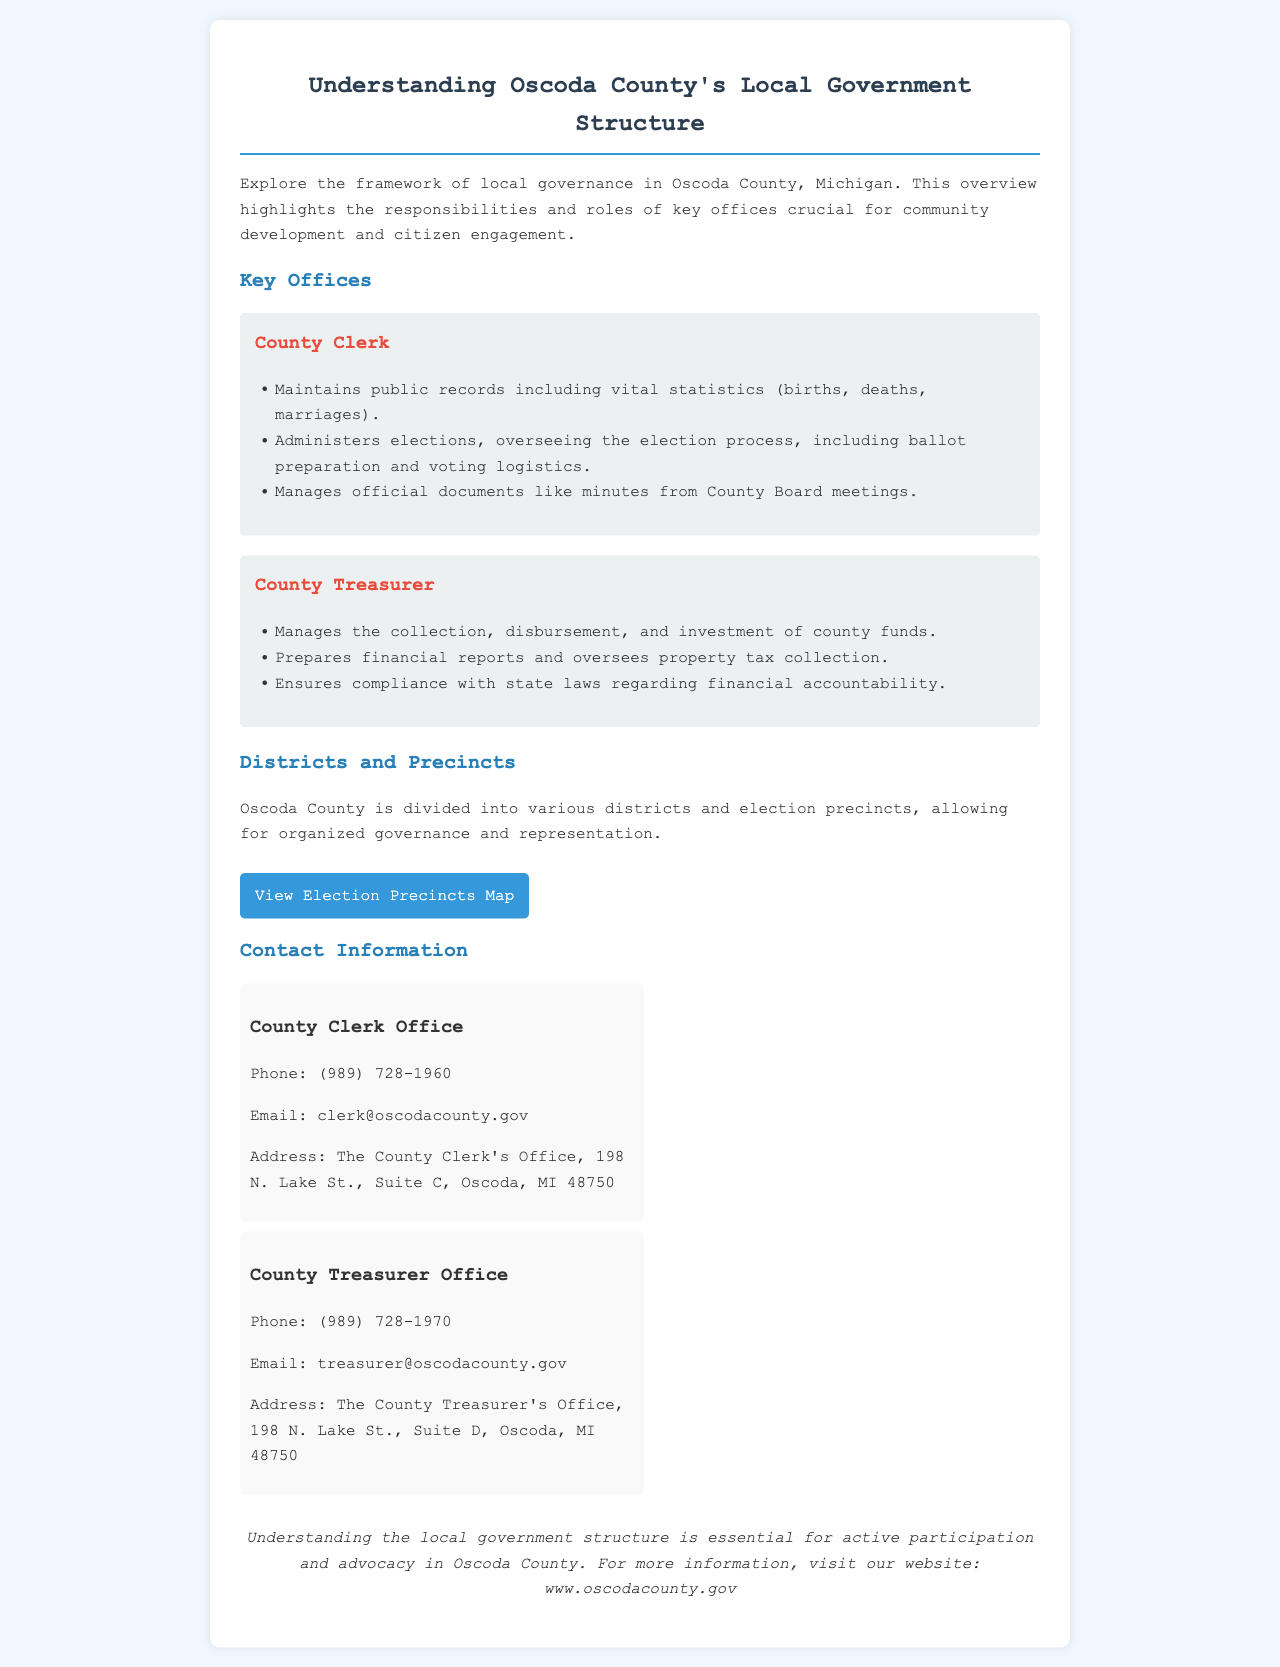What is the main focus of the brochure? The main focus of the brochure is to provide an overview of the local governance framework in Oscoda County, Michigan.
Answer: Local governance framework How many key offices are highlighted in the brochure? The brochure highlights two key offices: the County Clerk and the County Treasurer.
Answer: Two What is the phone number for the County Clerk Office? The phone number for the County Clerk Office is listed as (989) 728-1960.
Answer: (989) 728-1960 What task does the County Treasurer oversee? The County Treasurer oversees property tax collection.
Answer: Property tax collection Where is the County Clerk's Office located? The location of the County Clerk's Office is at 198 N. Lake St., Suite C, Oscoda, MI 48750.
Answer: 198 N. Lake St., Suite C, Oscoda, MI 48750 What document does the County Clerk administer regarding elections? The County Clerk administers the election process, including ballot preparation and voting logistics.
Answer: Election process What type of map is linked in the brochure? The linked map in the brochure is an Election Precincts Map.
Answer: Election Precincts Map How is Oscoda County divided for governance purposes? Oscoda County is divided into various districts and election precincts.
Answer: Districts and election precincts What is one responsibility of the County Treasurer? One responsibility of the County Treasurer is to prepare financial reports.
Answer: Prepare financial reports 